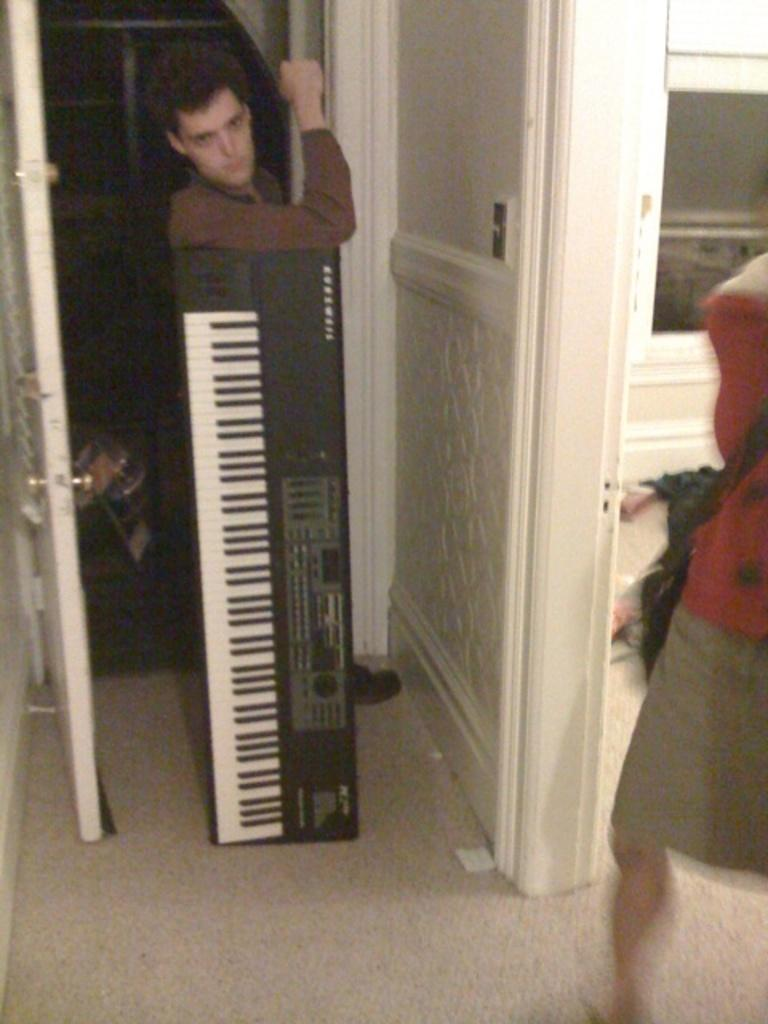What is the main subject in the center of the image? There is a person standing in the center of the image. What object can be seen in the image besides the person? There is a piano in the image. What feature of the room is visible in the image? There is a door in the image, which is used to enter the room. Can you describe the possible presence of another person in the image? There might be a woman on the right side of the image, but this is uncertain and should be considered tentative. How many books are on the plantation in the image? There is no plantation or books present in the image. What is the current hour as depicted in the image? There is no clock or indication of time in the image. 